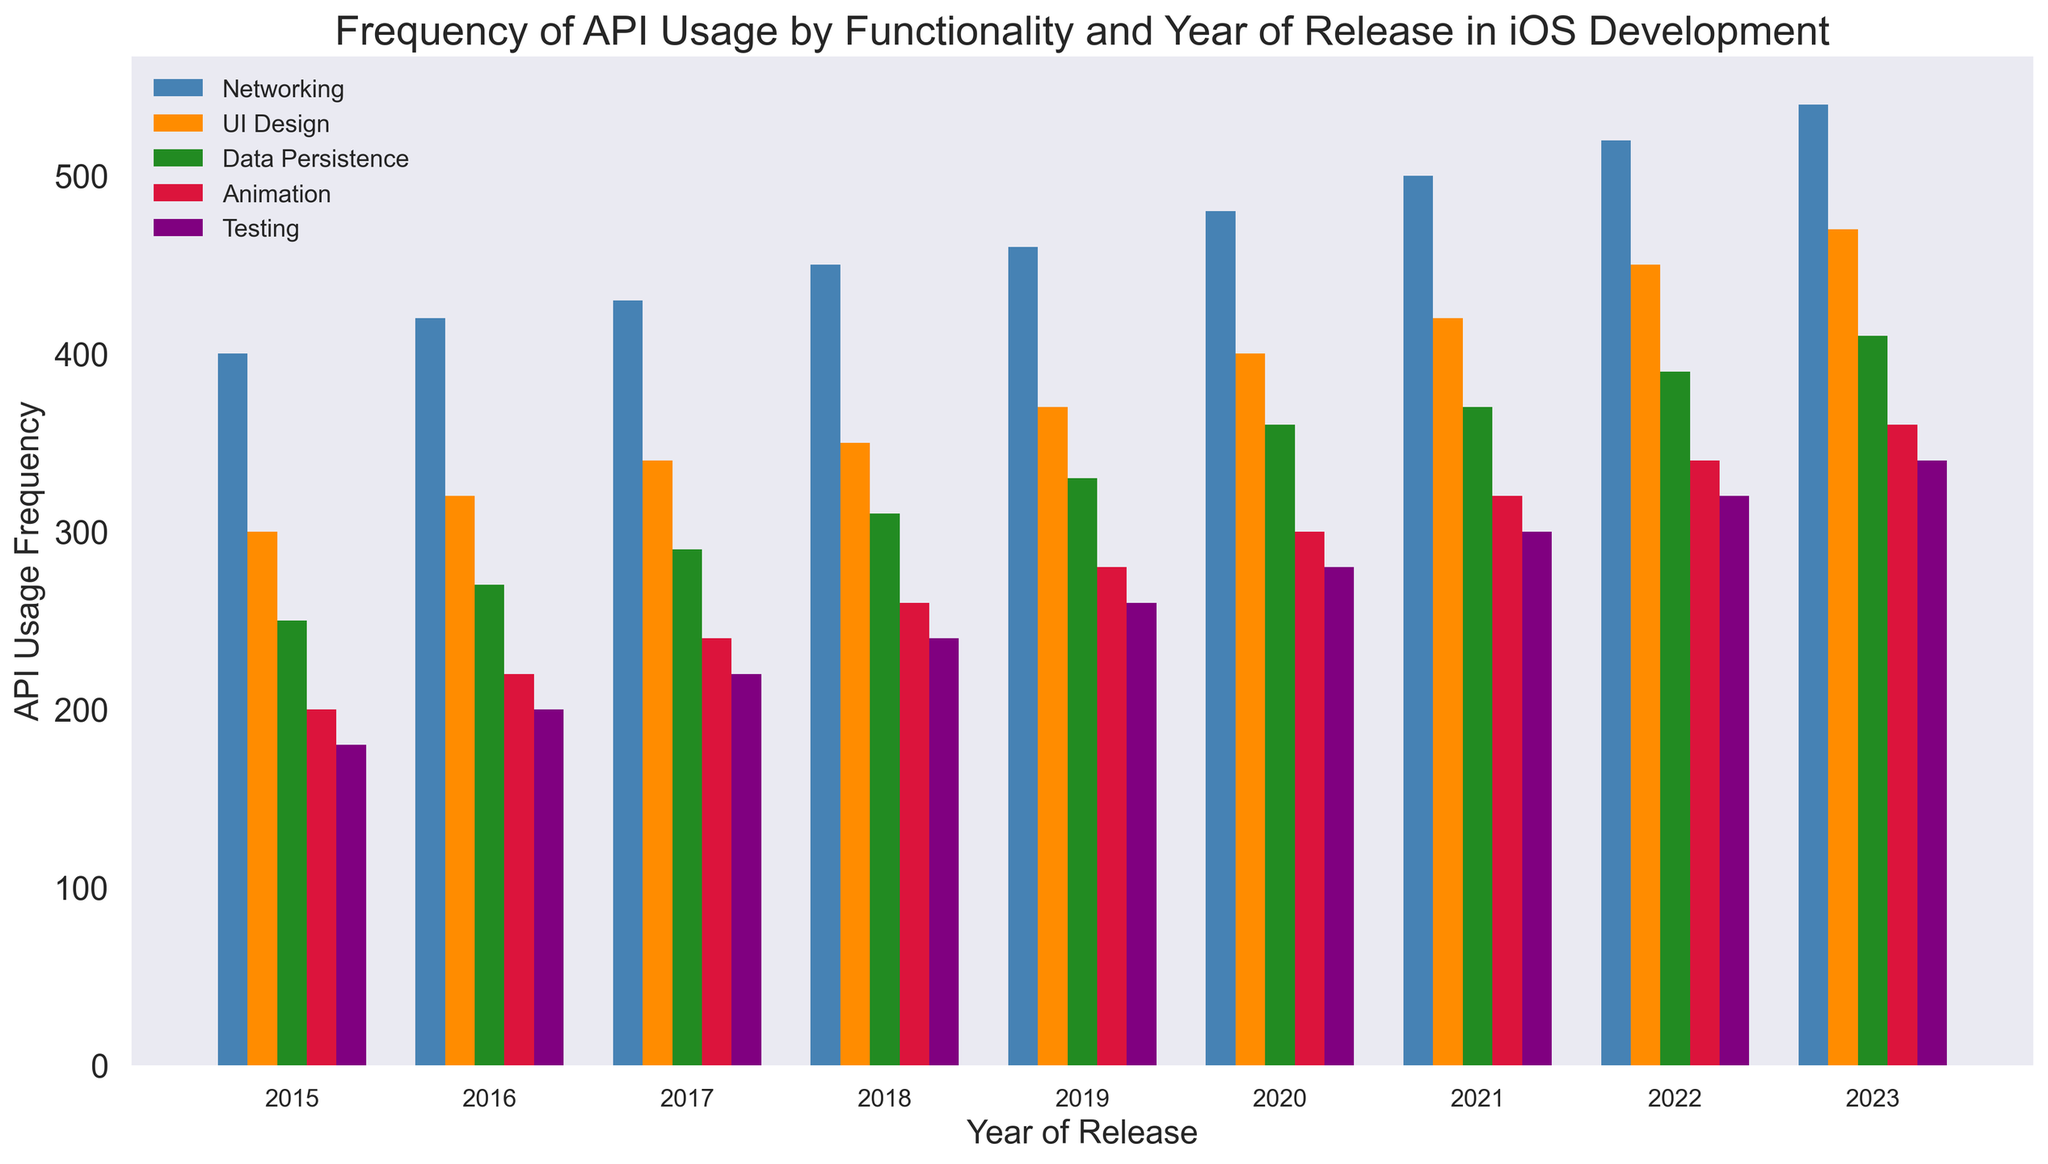What was the API usage frequency for Networking in 2020? Locate the bar for Networking in the year 2020, it is highlighted by the blue color and reaches the value of 480 on the y-axis.
Answer: 480 Between 2018 and 2019, which functionality showed the maximum increase in API usage frequency? Compare the bar heights for each functionality from 2018 to 2019. Networking increased by 10 (450 to 460), UI Design increased by 20 (350 to 370), Data Persistence increased by 20 (310 to 330), Animation increased by 20 (260 to 280), Testing increased by 20 (240 to 260). All showed the same increase.
Answer: All showed the same increase What is the average API usage frequency for UI Design from 2015 to 2023? Add the values for UI Design over the years and divide by the number of years. (300 + 320 + 340 + 350 + 370 + 400 + 420 + 450 + 470) / 9 = 3420 / 9 = 380
Answer: 380 Which functionality had the lowest API usage frequency in 2015? Look at the leftmost bars for all functionalities in 2015. The purple bar (Testing) is the lowest on the y-axis, showing a value of 180.
Answer: Testing Did any functionality have a consistent increase in API usage frequency each year from 2015 to 2023? Visually inspect each grouped set of bars for a consistent year-over-year increase. Each functionality shows a consistent increase over the years.
Answer: Yes, all functionalities By how much did the API usage frequency for Data Persistence increase from 2015 to 2023? Subtract the 2015 value from the 2023 value for Data Persistence. 410 - 250 = 160
Answer: 160 Which functionality had the highest API usage frequency in 2021? Compare the height of the bars for all functionalities in 2021. The blue bar (Networking) is the highest on the y-axis with a value of 500.
Answer: Networking How does the API usage frequency for Animation in 2017 compare to Testing in 2017? Look at the bars for Animation (red) and Testing (purple) in 2017. Animation's frequency is 240, while Testing's frequency is 220. Thus, Animation is higher.
Answer: Animation is higher 